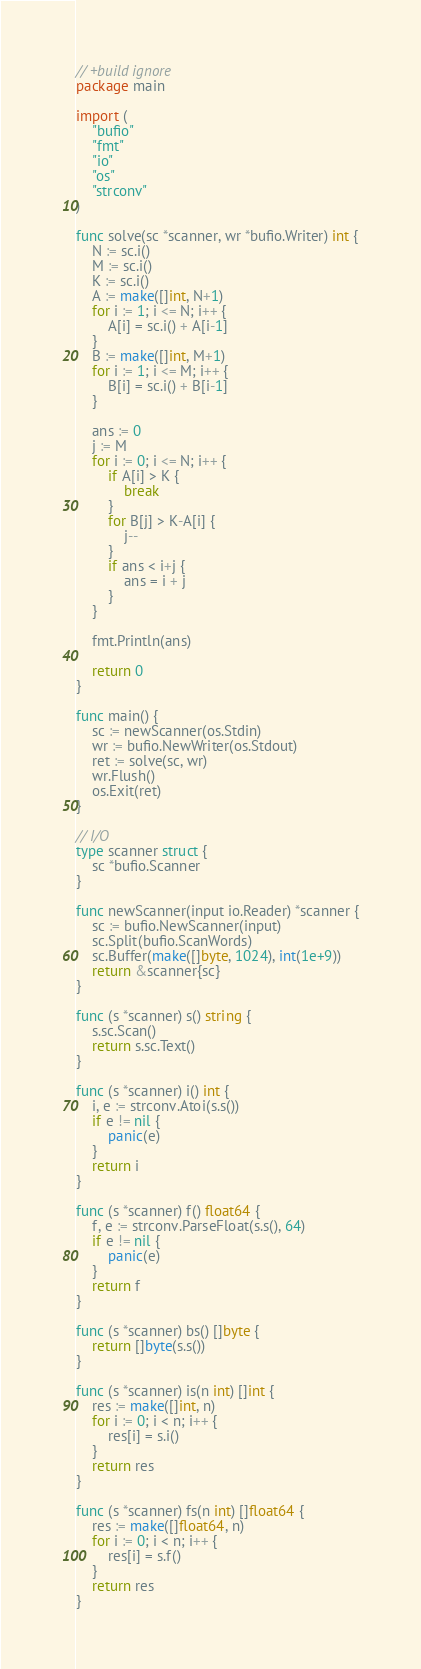<code> <loc_0><loc_0><loc_500><loc_500><_Go_>// +build ignore
package main

import (
	"bufio"
	"fmt"
	"io"
	"os"
	"strconv"
)

func solve(sc *scanner, wr *bufio.Writer) int {
	N := sc.i()
	M := sc.i()
	K := sc.i()
	A := make([]int, N+1)
	for i := 1; i <= N; i++ {
		A[i] = sc.i() + A[i-1]
	}
	B := make([]int, M+1)
	for i := 1; i <= M; i++ {
		B[i] = sc.i() + B[i-1]
	}

	ans := 0
	j := M
	for i := 0; i <= N; i++ {
		if A[i] > K {
			break
		}
		for B[j] > K-A[i] {
			j--
		}
		if ans < i+j {
			ans = i + j
		}
	}

	fmt.Println(ans)

	return 0
}

func main() {
	sc := newScanner(os.Stdin)
	wr := bufio.NewWriter(os.Stdout)
	ret := solve(sc, wr)
	wr.Flush()
	os.Exit(ret)
}

// I/O
type scanner struct {
	sc *bufio.Scanner
}

func newScanner(input io.Reader) *scanner {
	sc := bufio.NewScanner(input)
	sc.Split(bufio.ScanWords)
	sc.Buffer(make([]byte, 1024), int(1e+9))
	return &scanner{sc}
}

func (s *scanner) s() string {
	s.sc.Scan()
	return s.sc.Text()
}

func (s *scanner) i() int {
	i, e := strconv.Atoi(s.s())
	if e != nil {
		panic(e)
	}
	return i
}

func (s *scanner) f() float64 {
	f, e := strconv.ParseFloat(s.s(), 64)
	if e != nil {
		panic(e)
	}
	return f
}

func (s *scanner) bs() []byte {
	return []byte(s.s())
}

func (s *scanner) is(n int) []int {
	res := make([]int, n)
	for i := 0; i < n; i++ {
		res[i] = s.i()
	}
	return res
}

func (s *scanner) fs(n int) []float64 {
	res := make([]float64, n)
	for i := 0; i < n; i++ {
		res[i] = s.f()
	}
	return res
}
</code> 